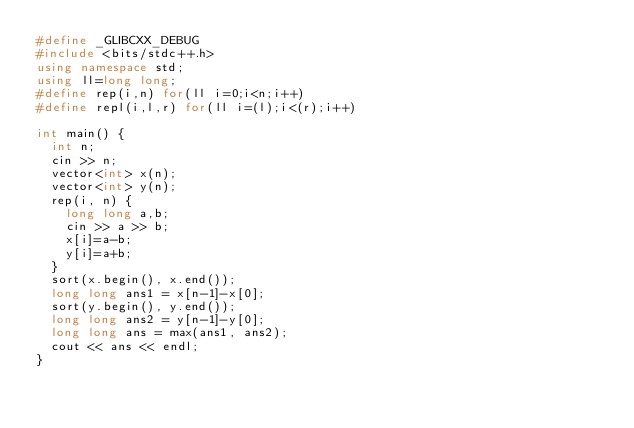Convert code to text. <code><loc_0><loc_0><loc_500><loc_500><_C++_>#define _GLIBCXX_DEBUG
#include <bits/stdc++.h>
using namespace std;
using ll=long long;
#define rep(i,n) for(ll i=0;i<n;i++)
#define repl(i,l,r) for(ll i=(l);i<(r);i++)

int main() {
  int n;
  cin >> n;
  vector<int> x(n);
  vector<int> y(n);
  rep(i, n) {
    long long a,b;
    cin >> a >> b;
    x[i]=a-b;
    y[i]=a+b;
  }
  sort(x.begin(), x.end());
  long long ans1 = x[n-1]-x[0];
  sort(y.begin(), y.end());
  long long ans2 = y[n-1]-y[0];
  long long ans = max(ans1, ans2);
  cout << ans << endl;
}</code> 